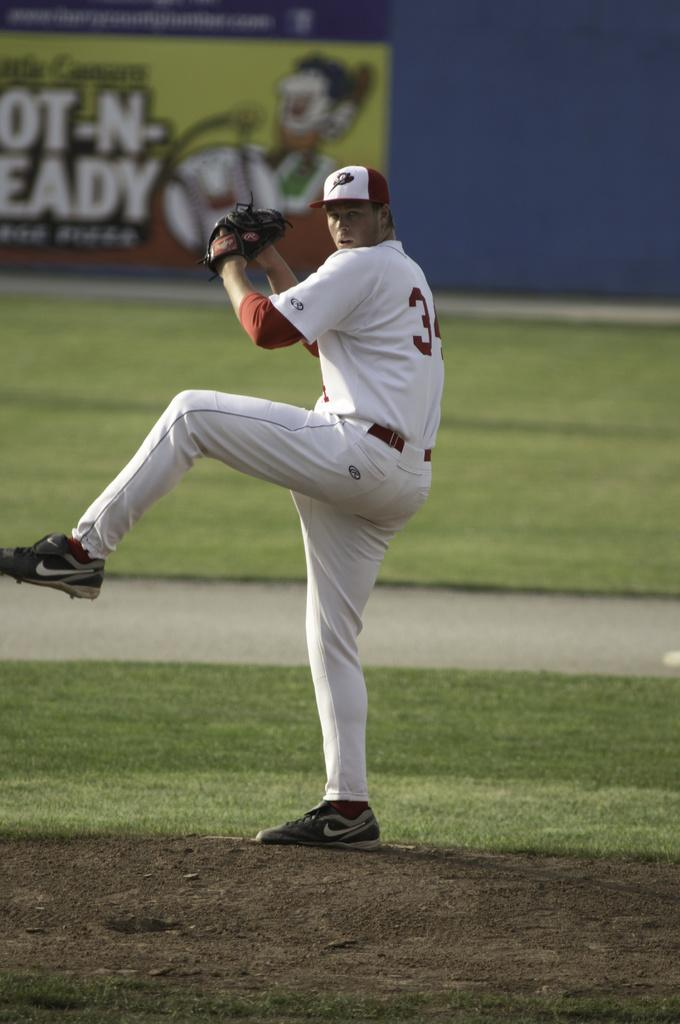<image>
Summarize the visual content of the image. The pitcher of a baseball team with the number 3 on his uniform winds up for a pitch in front of a banner for Little Ceasars Hot-N-Ready pizzas. 